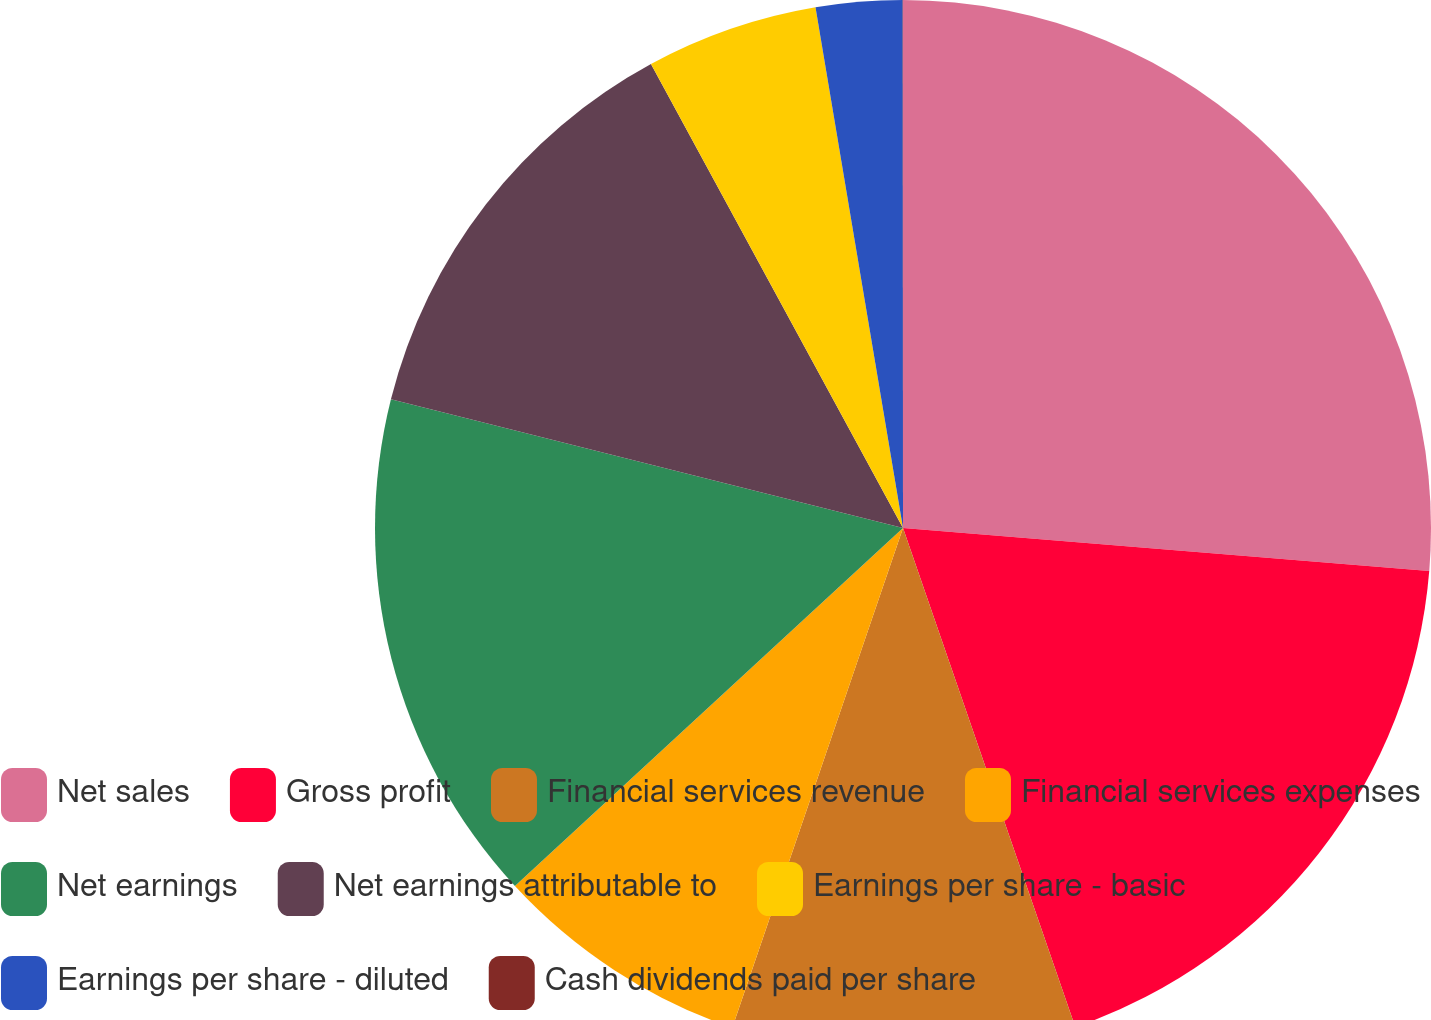Convert chart. <chart><loc_0><loc_0><loc_500><loc_500><pie_chart><fcel>Net sales<fcel>Gross profit<fcel>Financial services revenue<fcel>Financial services expenses<fcel>Net earnings<fcel>Net earnings attributable to<fcel>Earnings per share - basic<fcel>Earnings per share - diluted<fcel>Cash dividends paid per share<nl><fcel>26.3%<fcel>18.41%<fcel>10.53%<fcel>7.9%<fcel>15.78%<fcel>13.16%<fcel>5.27%<fcel>2.64%<fcel>0.01%<nl></chart> 